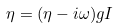Convert formula to latex. <formula><loc_0><loc_0><loc_500><loc_500>\eta = ( \eta - i \omega ) g I</formula> 